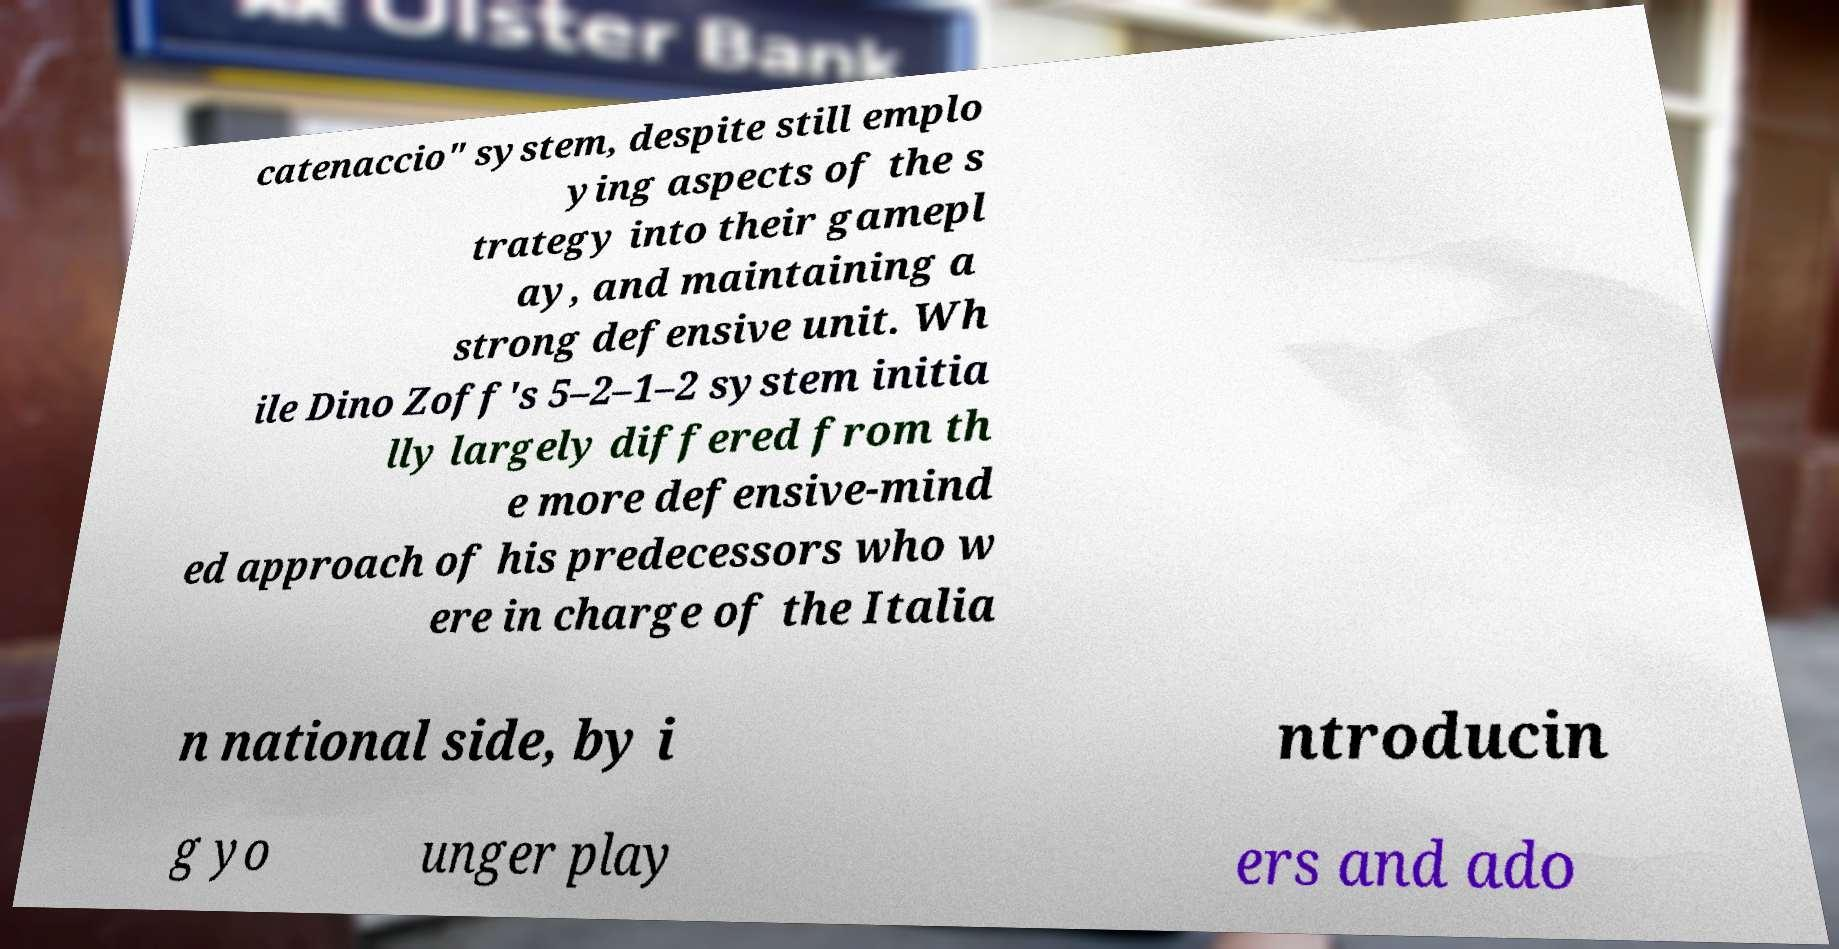What messages or text are displayed in this image? I need them in a readable, typed format. catenaccio" system, despite still emplo ying aspects of the s trategy into their gamepl ay, and maintaining a strong defensive unit. Wh ile Dino Zoff's 5–2–1–2 system initia lly largely differed from th e more defensive-mind ed approach of his predecessors who w ere in charge of the Italia n national side, by i ntroducin g yo unger play ers and ado 